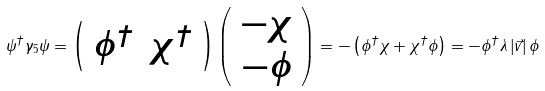<formula> <loc_0><loc_0><loc_500><loc_500>\psi ^ { \dagger } \gamma _ { 5 } \psi = \left ( \begin{array} { c c } \phi ^ { \dagger } & \chi ^ { \dagger } \\ \end{array} \right ) \left ( \begin{array} { c } - \chi \\ - \phi \end{array} \right ) = - \left ( \phi ^ { \dagger } \chi + \chi ^ { \dagger } \phi \right ) = - \phi ^ { \dagger } \lambda \left | \vec { v } \right | \phi</formula> 